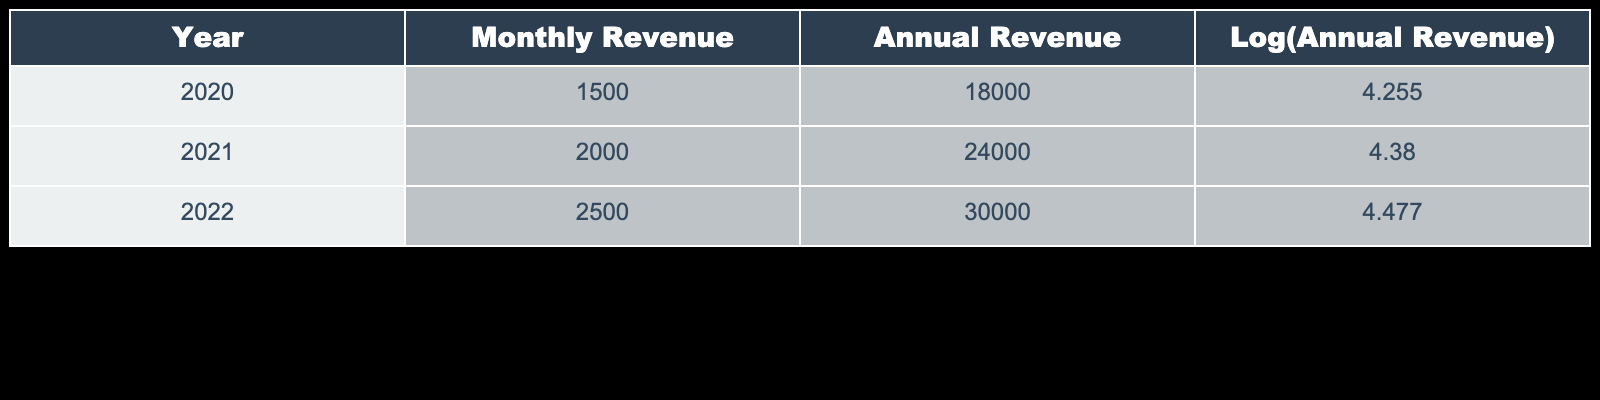What was the monthly revenue in 2021? The table shows that the monthly revenue for the year 2021 is explicitly listed as 2000.
Answer: 2000 What is the annual revenue for 2022? According to the table, the annual revenue for the year 2022 is stated as 30000.
Answer: 30000 Did the annual revenue increase from 2020 to 2021? By comparing the annual revenue in 2020 (18000) and in 2021 (24000), it can be seen that 24000 is greater than 18000, indicating an increase.
Answer: Yes What is the percentage increase in annual revenue from 2021 to 2022? The annual revenue for 2021 is 24000 and for 2022 is 30000. The increase is calculated as (30000 - 24000) / 24000 * 100 = 25%.
Answer: 25% What was the total annual revenue over all three years combined? To find the total annual revenue, we sum the annual revenues of each year: 18000 + 24000 + 30000 = 72000.
Answer: 72000 Which year had the highest logarithmic value of annual revenue? The logarithmic values in the table show that 4.477 (for 2022) is the highest among the values for all three years (4.255 for 2020 and 4.380 for 2021).
Answer: 2022 What was the average monthly revenue from 2020 to 2022? The monthly revenues are 1500, 2000, and 2500. Summing these gives 1500 + 2000 + 2500 = 6000, then dividing by 3 yields an average of 2000.
Answer: 2000 Does the table indicate that the monthly revenue was consistently increasing each year? The monthly revenues for the years listed are 1500, 2000, and 2500. Since each subsequent year has a higher value than the previous, this indicates consistency in increase.
Answer: Yes What is the difference in logarithmic values of annual revenue between 2020 and 2021? The logarithmic values for 2020 and 2021 are 4.255 and 4.380. Therefore, the difference is 4.380 - 4.255 = 0.125.
Answer: 0.125 